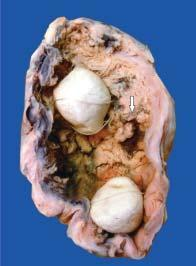re two multi-faceted gallstones also present in the lumen?
Answer the question using a single word or phrase. Yes 